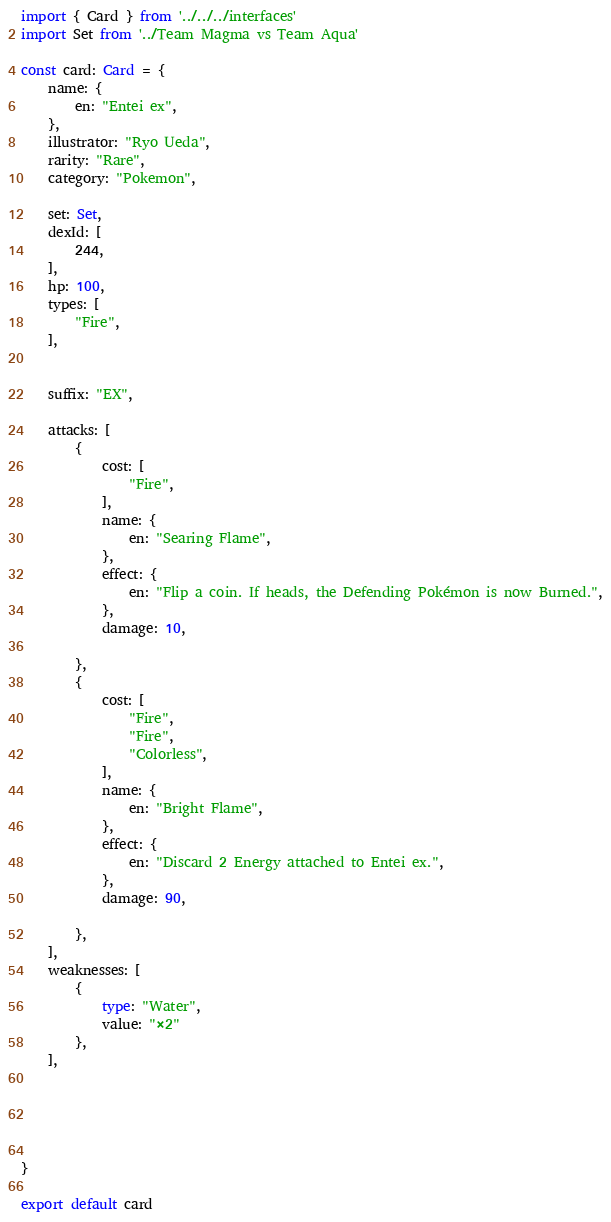Convert code to text. <code><loc_0><loc_0><loc_500><loc_500><_TypeScript_>import { Card } from '../../../interfaces'
import Set from '../Team Magma vs Team Aqua'

const card: Card = {
	name: {
		en: "Entei ex",
	},
	illustrator: "Ryo Ueda",
	rarity: "Rare",
	category: "Pokemon",

	set: Set,
	dexId: [
		244,
	],
	hp: 100,
	types: [
		"Fire",
	],


	suffix: "EX",

	attacks: [
		{
			cost: [
				"Fire",
			],
			name: {
				en: "Searing Flame",
			},
			effect: {
				en: "Flip a coin. If heads, the Defending Pokémon is now Burned.",
			},
			damage: 10,

		},
		{
			cost: [
				"Fire",
				"Fire",
				"Colorless",
			],
			name: {
				en: "Bright Flame",
			},
			effect: {
				en: "Discard 2 Energy attached to Entei ex.",
			},
			damage: 90,

		},
	],
	weaknesses: [
		{
			type: "Water",
			value: "×2"
		},
	],





}

export default card
</code> 